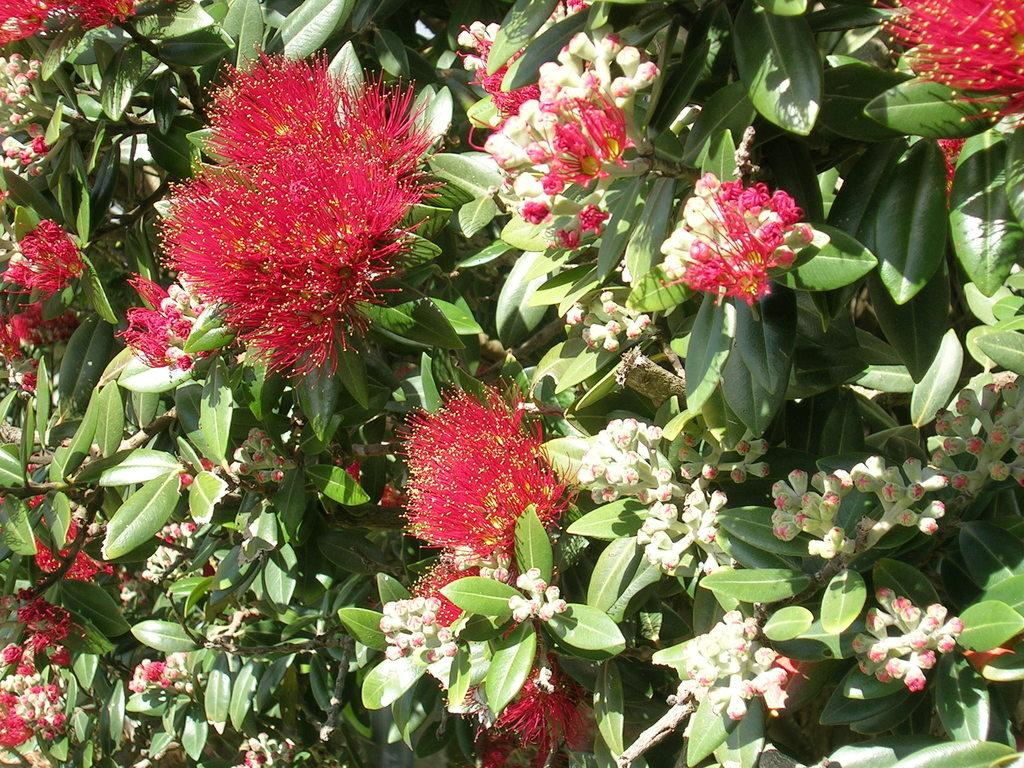What type of living organisms can be seen in the image? There are flowers and plants in the image. Can you describe the plants in the image? The plants in the image are not specified, but they are present alongside the flowers. What type of paste is being used to create pleasure in the image? There is no paste or indication of pleasure in the image; it features flowers and plants. 